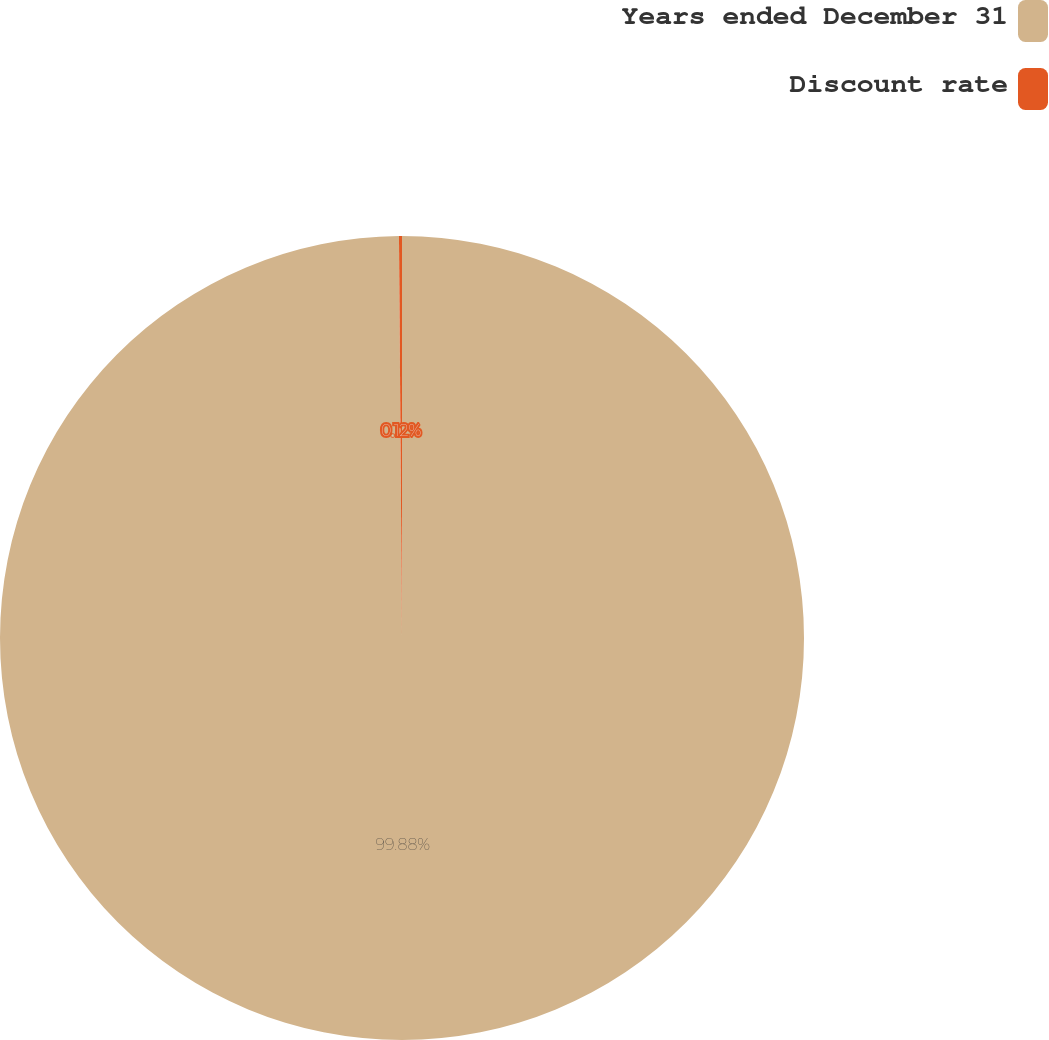<chart> <loc_0><loc_0><loc_500><loc_500><pie_chart><fcel>Years ended December 31<fcel>Discount rate<nl><fcel>99.88%<fcel>0.12%<nl></chart> 